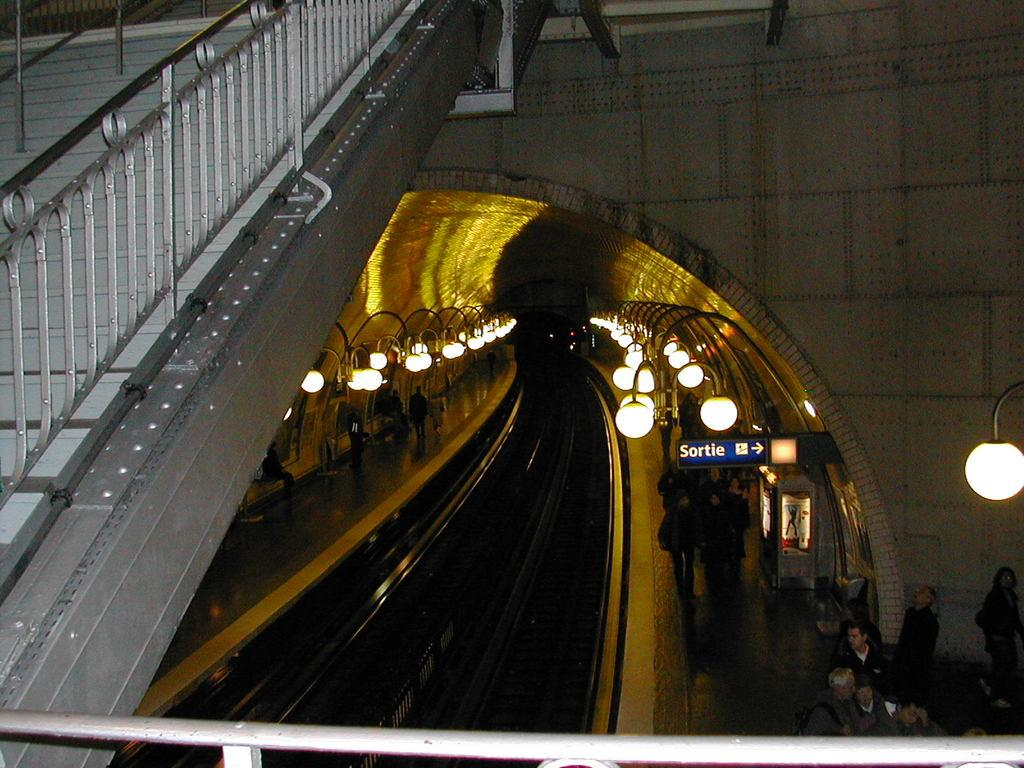What type of barrier can be seen in the image? There is a fence in the image. What type of structure can also be seen in the image? There is a wall in the image. What can be seen illuminating the area in the image? There are lights in the image. Are there any people present in the image? Yes, there are people in the image. Can you describe what is visible in the background of the image? In the background, there are people, lights, a board, and tracks. What type of curtain is hanging from the board in the background? There is no curtain present in the image; the background features a board, lights, tracks, and people, but no curtains. What caused the burst of light in the image? There is no burst of light in the image; the lights are simply illuminating the area. 